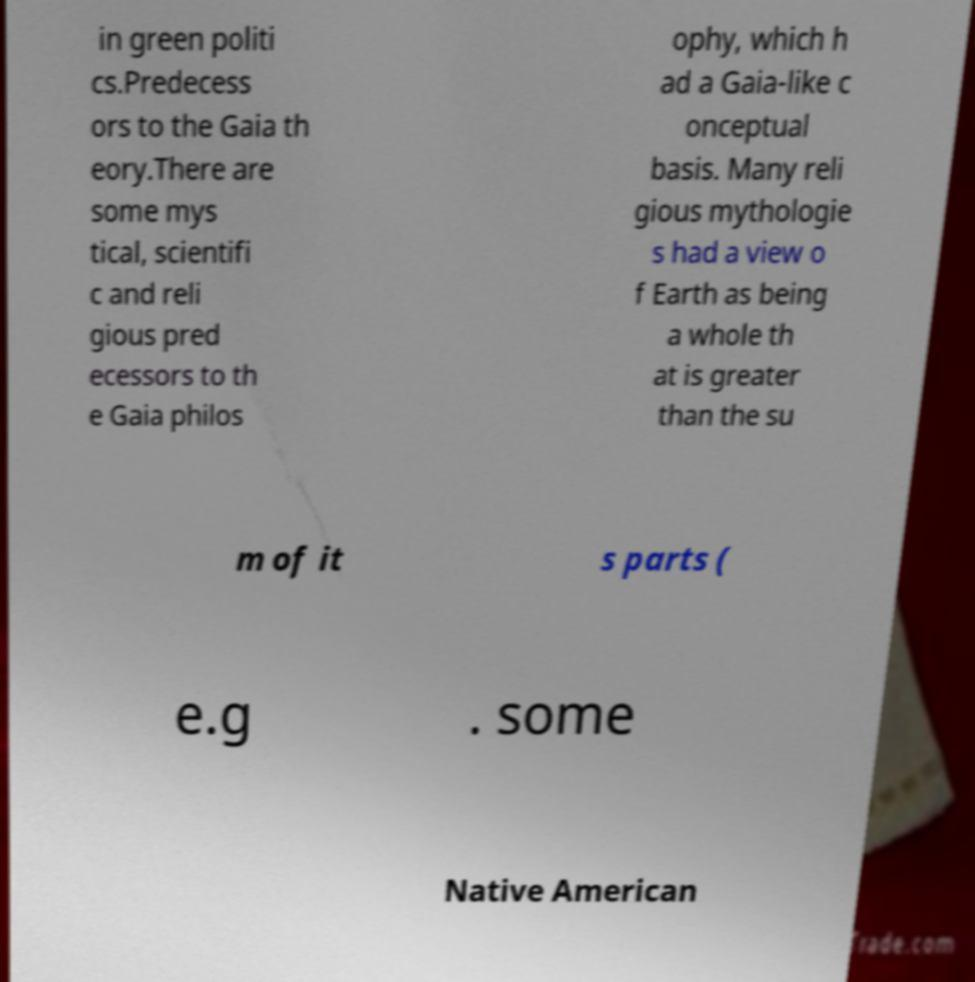Please identify and transcribe the text found in this image. in green politi cs.Predecess ors to the Gaia th eory.There are some mys tical, scientifi c and reli gious pred ecessors to th e Gaia philos ophy, which h ad a Gaia-like c onceptual basis. Many reli gious mythologie s had a view o f Earth as being a whole th at is greater than the su m of it s parts ( e.g . some Native American 